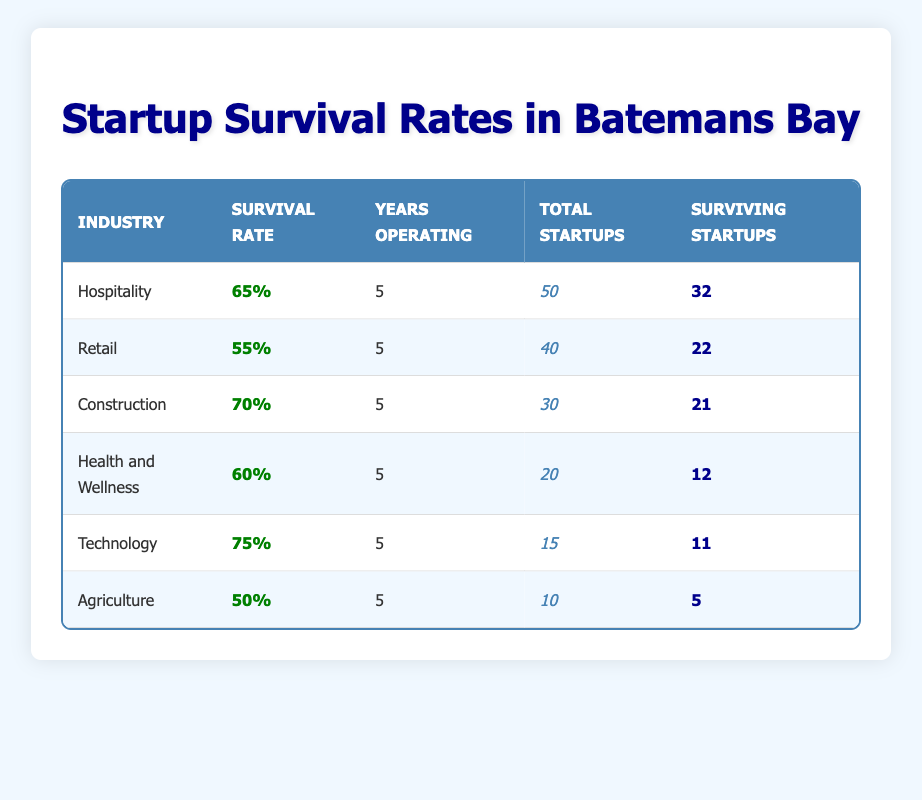What is the survival rate for Technology startups? The survival rate for Technology startups is listed in the table under the "Survival Rate" column for the "Technology" industry, which shows 75%.
Answer: 75% Which industry has the lowest survival rate among the listed sectors? To find the lowest survival rate, we compare the survival rates of all industries: Hospitality (65%), Retail (55%), Construction (70%), Health and Wellness (60%), Technology (75%), and Agriculture (50%). Agriculture has the lowest at 50%.
Answer: Agriculture How many total startups are there in the Construction industry? The total number of startups in the Construction industry is given directly in the table under the "Total Startups" column for the "Construction" row, which states 30.
Answer: 30 What is the average survival rate of all the industries listed? To calculate the average survival rate, we sum the survival rates: 65 + 55 + 70 + 60 + 75 + 50 = 375. Then divide by the number of industries (6): 375/6 = 62.5%.
Answer: 62.5% Are there more surviving startups in the Hospitality sector than in the Health and Wellness sector? In the table, under "Surviving Startups," Hospitality has 32 and Health and Wellness has 12. Comparing these values, 32 is greater than 12, so yes, there are more surviving startups in Hospitality.
Answer: Yes What is the total number of surviving startups across all industries? To find the total number of surviving startups, we add the numbers from the "Surviving Startups" column: 32 + 22 + 21 + 12 + 11 + 5 = 113.
Answer: 113 Which industry has the highest number of startups and what is their survival rate? By inspecting the "Total Startups" column, we see that Hospitality has the highest total at 50. Its survival rate, listed in the same row under "Survival Rate," is 65%.
Answer: Hospitality, 65% If a startup in the Agriculture sector were to increase their survival rate to match the average rate of the other industries, how much would that increase be? The current survival rate for Agriculture is 50%. The average survival rate of the other industries is 62.5%. The increase needed would be 62.5 - 50 = 12.5%.
Answer: 12.5% 